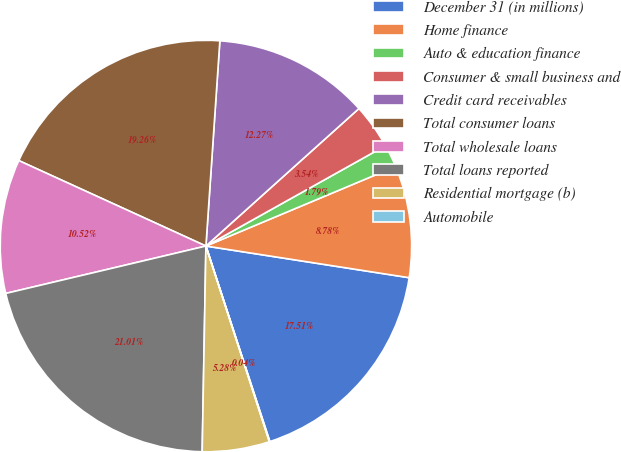<chart> <loc_0><loc_0><loc_500><loc_500><pie_chart><fcel>December 31 (in millions)<fcel>Home finance<fcel>Auto & education finance<fcel>Consumer & small business and<fcel>Credit card receivables<fcel>Total consumer loans<fcel>Total wholesale loans<fcel>Total loans reported<fcel>Residential mortgage (b)<fcel>Automobile<nl><fcel>17.51%<fcel>8.78%<fcel>1.79%<fcel>3.54%<fcel>12.27%<fcel>19.26%<fcel>10.52%<fcel>21.01%<fcel>5.28%<fcel>0.04%<nl></chart> 